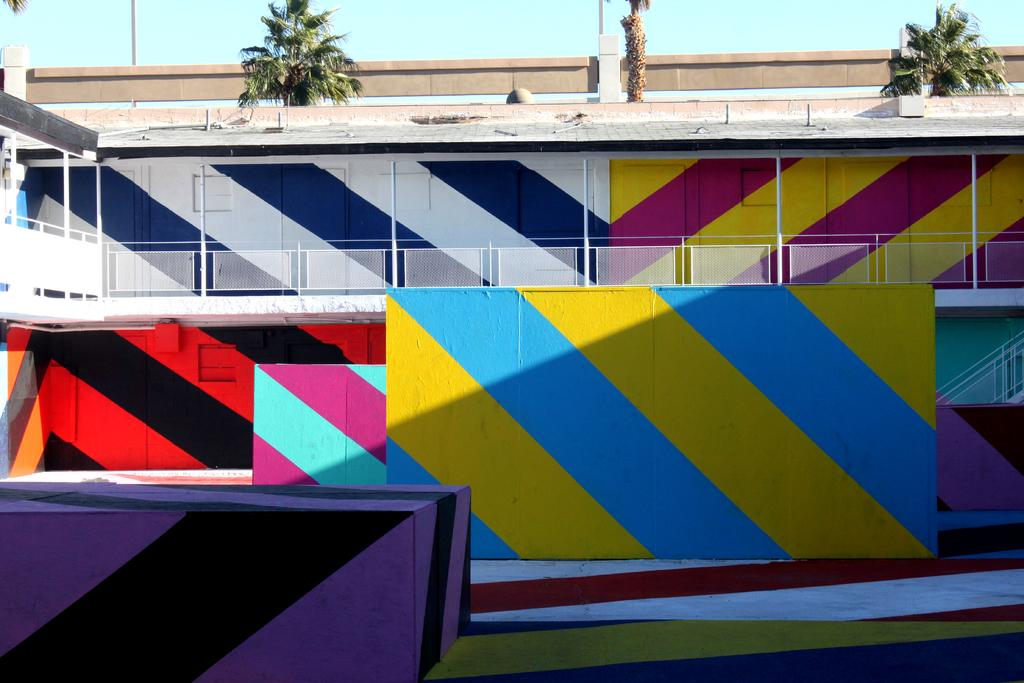What is depicted on the wall in the image? There is a painting on the wall in the image. What type of structure can be seen in the image? There is a fence and a pole in the image. What architectural element is present in the image? There is a pillar in the image. What type of vegetation is visible in the image? There are trees in the image. What is visible in the background of the image? The sky is visible in the image. How many mice are hiding behind the pillar in the image? There are no mice present in the image; it only features a painting on the wall, a fence, a pole, a pillar, trees, and the sky. What type of laborer is working on the painting in the image? There is no laborer present in the image, nor is there any indication that the painting is being worked on. 